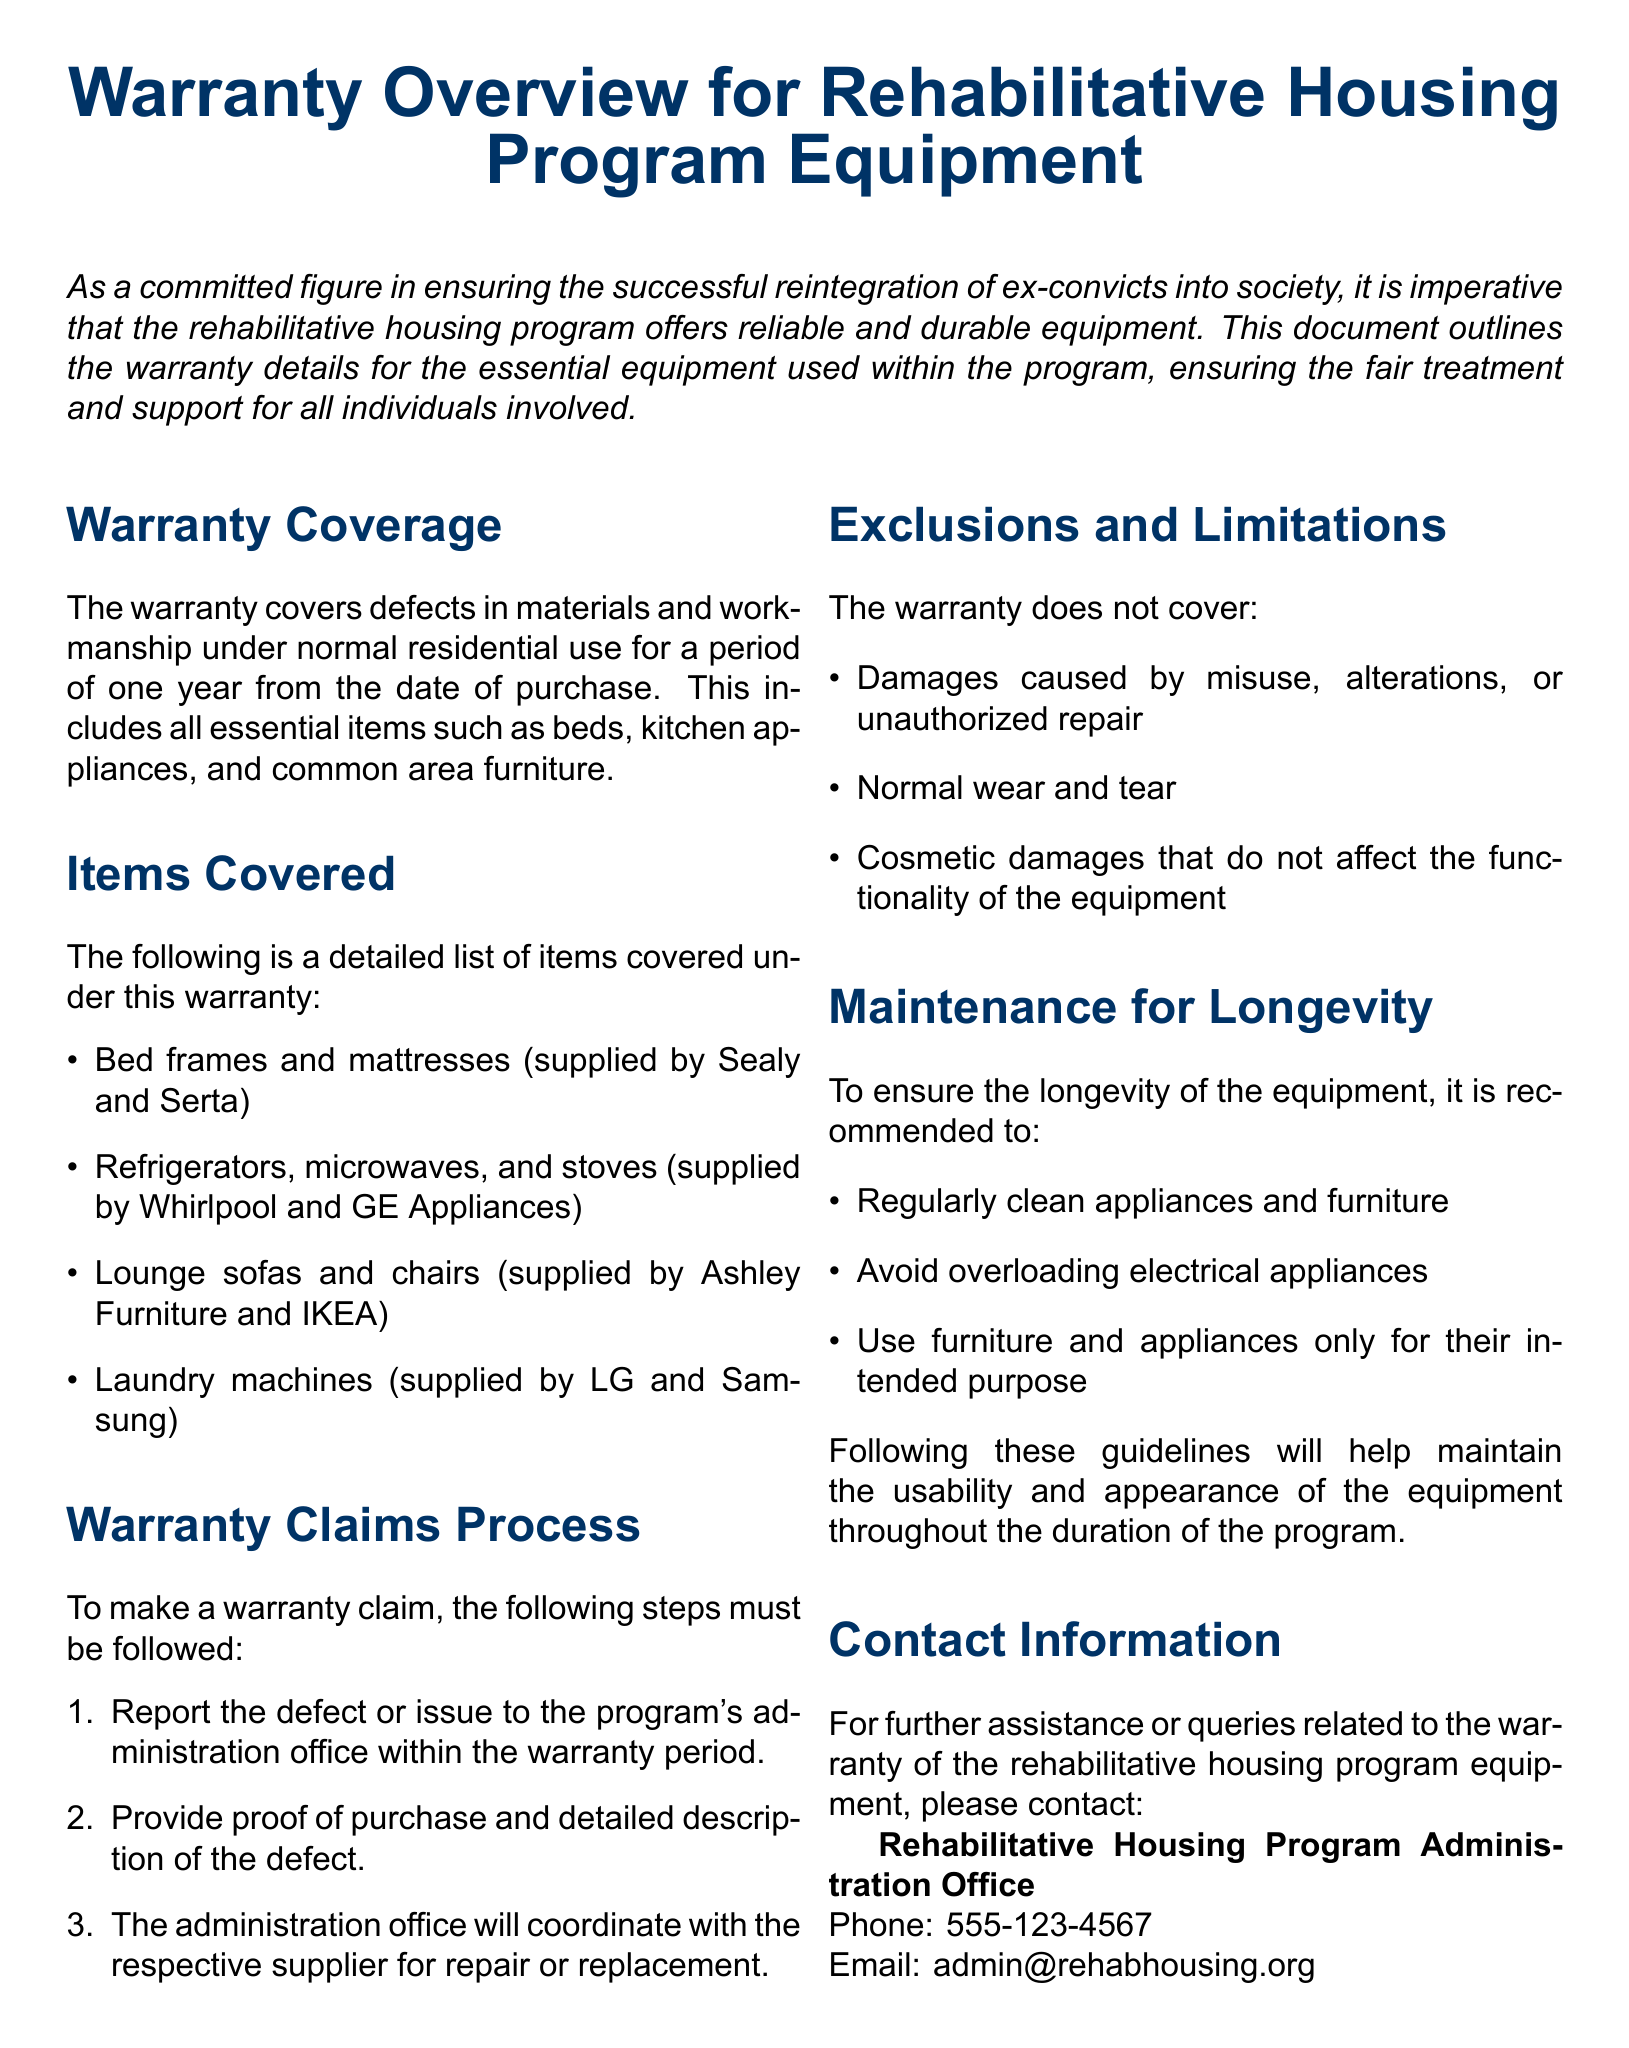What is the warranty period? The warranty covers defects for a period of one year from the date of purchase.
Answer: one year Which items are covered under the warranty? The list includes items such as bed frames and mattresses, refrigerators, lounge sofas, and laundry machines.
Answer: bed frames, refrigerators, lounge sofas, laundry machines Who are the suppliers for mattresses? The warranty mentions the suppliers for bed frames and mattresses as Sealy and Serta.
Answer: Sealy and Serta What must be provided to make a warranty claim? The document specifies that proof of purchase and a detailed description of the defect must be provided.
Answer: proof of purchase and detailed description of the defect What type of damages are excluded from the warranty? The exclusions include damages caused by misuse, normal wear and tear, and cosmetic damages.
Answer: misuse, normal wear and tear, cosmetic damages What is recommended for equipment maintenance? Regular cleaning of appliances and furniture is recommended for longevity.
Answer: Regularly clean appliances and furniture What is the contact phone number for further assistance? The document provides a contact number for the Rehabilitative Housing Program Administration Office.
Answer: 555-123-4567 What appliances does the warranty cover from Whirlpool? The warranty document lists which items are covered and identifies refrigerators as one of the items.
Answer: refrigerators What should one avoid to ensure longevity of equipment? The document advises against overloading electrical appliances for maintenance.
Answer: Avoid overloading electrical appliances 